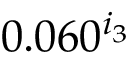<formula> <loc_0><loc_0><loc_500><loc_500>0 . 0 6 0 ^ { i _ { 3 } }</formula> 